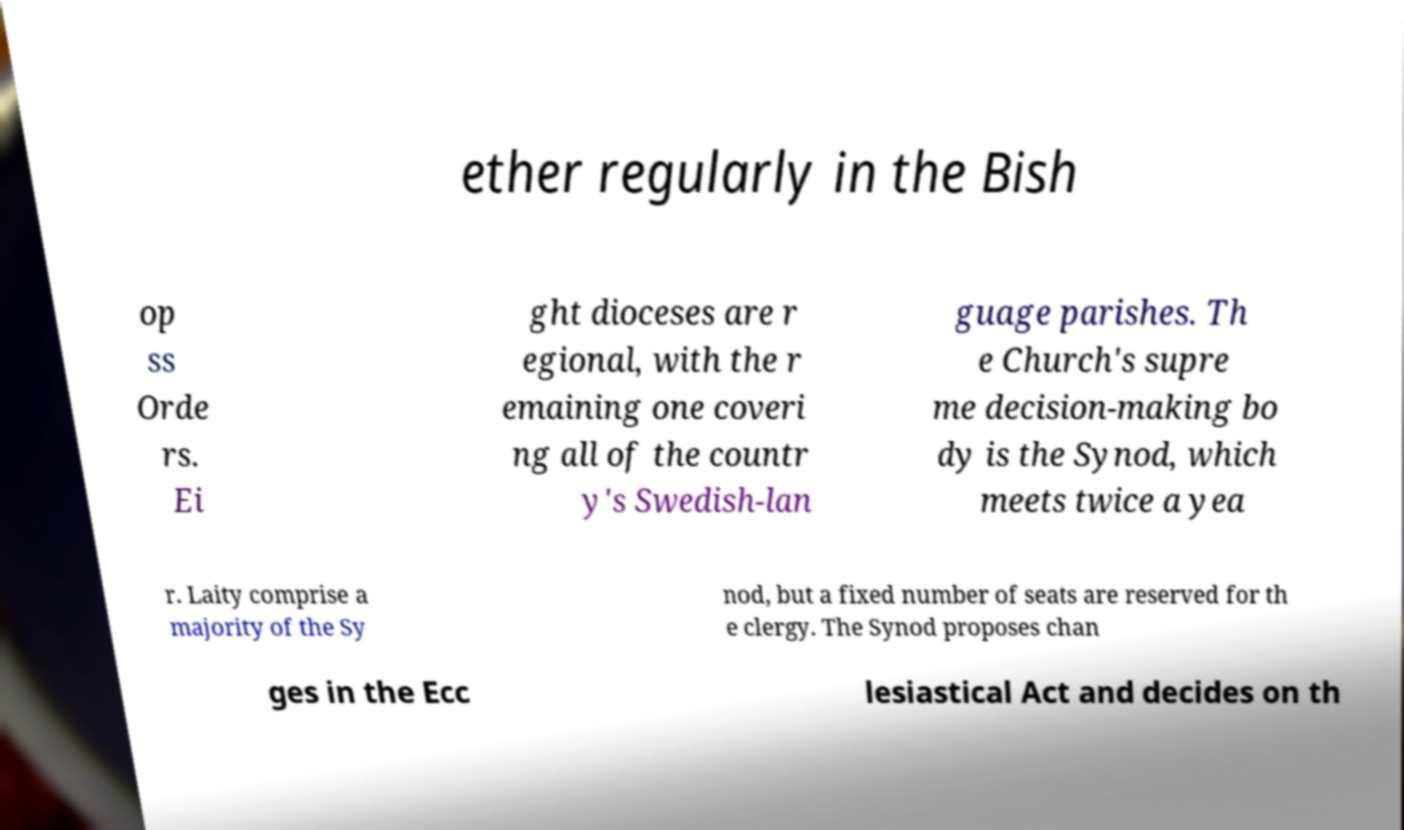Could you assist in decoding the text presented in this image and type it out clearly? ether regularly in the Bish op ss Orde rs. Ei ght dioceses are r egional, with the r emaining one coveri ng all of the countr y's Swedish-lan guage parishes. Th e Church's supre me decision-making bo dy is the Synod, which meets twice a yea r. Laity comprise a majority of the Sy nod, but a fixed number of seats are reserved for th e clergy. The Synod proposes chan ges in the Ecc lesiastical Act and decides on th 